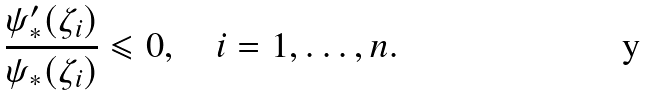Convert formula to latex. <formula><loc_0><loc_0><loc_500><loc_500>\frac { \psi ^ { \prime } _ { * } ( \zeta _ { i } ) } { \psi _ { * } ( \zeta _ { i } ) } \leqslant 0 , \quad i = 1 , \dots , n .</formula> 